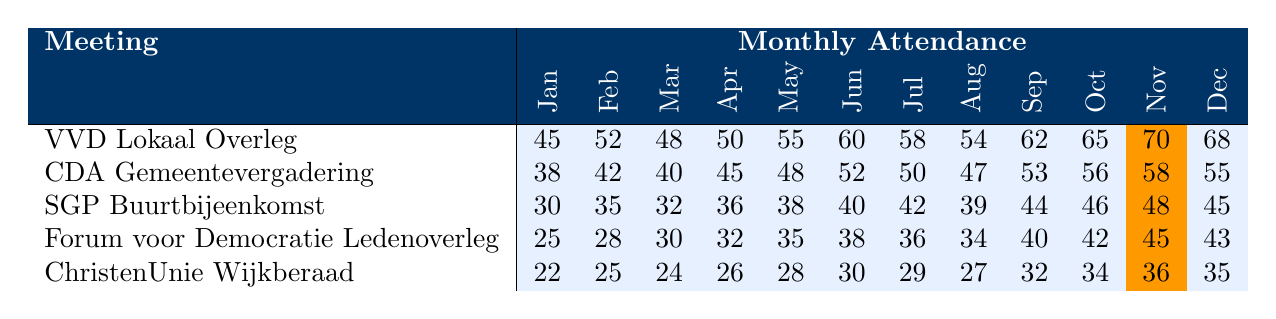What was the highest attendance at the VVD Lokaal Overleg in any month? The numbers in the VVD Lokaal Overleg row show a peak attendance of 70 in November.
Answer: 70 Which month saw the lowest attendance for the Forum voor Democratie Ledenoverleg? The Forum voor Democratie Ledenoverleg had the lowest attendance of 25 in January.
Answer: 25 How many people attended CDA Gemeentevergadering in September? The September attendance for CDA Gemeentevergadering is listed as 53.
Answer: 53 What is the average attendance for the SGP Buurtbijeenkomst over the year? The total attendance for SGP Buurtbijeenkomst is 30 + 35 + 32 + 36 + 38 + 40 + 42 + 39 + 44 + 46 + 48 + 45 =  505. There are 12 data points, so the average is 505 / 12 ≈ 42.08.
Answer: 42.08 Which meeting had the highest attendance in June? The attendance for June are as follows: VVD Lokaal Overleg (60), CDA Gemeentevergadering (52), SGP Buurtbijeenkomst (40), Forum voor Democratie (38), and ChristenUnie (30). The highest is VVD Lokaal Overleg with 60.
Answer: VVD Lokaal Overleg What was the overall trend in attendance for VVD Lokaal Overleg from January to December? Attendance shows an increase from 45 in January to 70 in November, then it slightly decreases to 68 in December, indicating an upward trend overall with a peak in November.
Answer: Upward trend with a peak in November Did attendance at the ChristenUnie Wijkberaad exceed 30 in the last three months of the year? The attendance for ChristenUnie in the last three months are October (34), November (36), and December (35). All three months had attendance above 30, confirming the statement.
Answer: Yes Which political meeting had the more consistent attendance throughout the year, based on the data? The SGP Buurtbijeenkomst shows fewer fluctuations, ranging from a low of 30 to a high of 48 with steady increases most months. In contrast, other meetings show more variable attendance numbers.
Answer: SGP Buurtbijeenkomst What is the difference in attendance between the meeting with the highest and the lowest attendance in December? In December, the highest attendance is VVD Lokaal Overleg with 68 and the lowest is ChristenUnie Wijkberaad with 35. The difference is 68 - 35 = 33.
Answer: 33 How did the attendance for Forum voor Democratie Ledenoverleg in March compare to that in October? The attendance in March is 30 and in October is 42. Therefore, March had 12 fewer attendees than October.
Answer: 12 fewer attendees Which meeting consistently had the lowest attendance compared to the others? Throughout the year, Forum voor Democratie Ledenoverleg shows the lowest numbers, often falling below the other meetings in each month.
Answer: Forum voor Democratie Ledenoverleg 